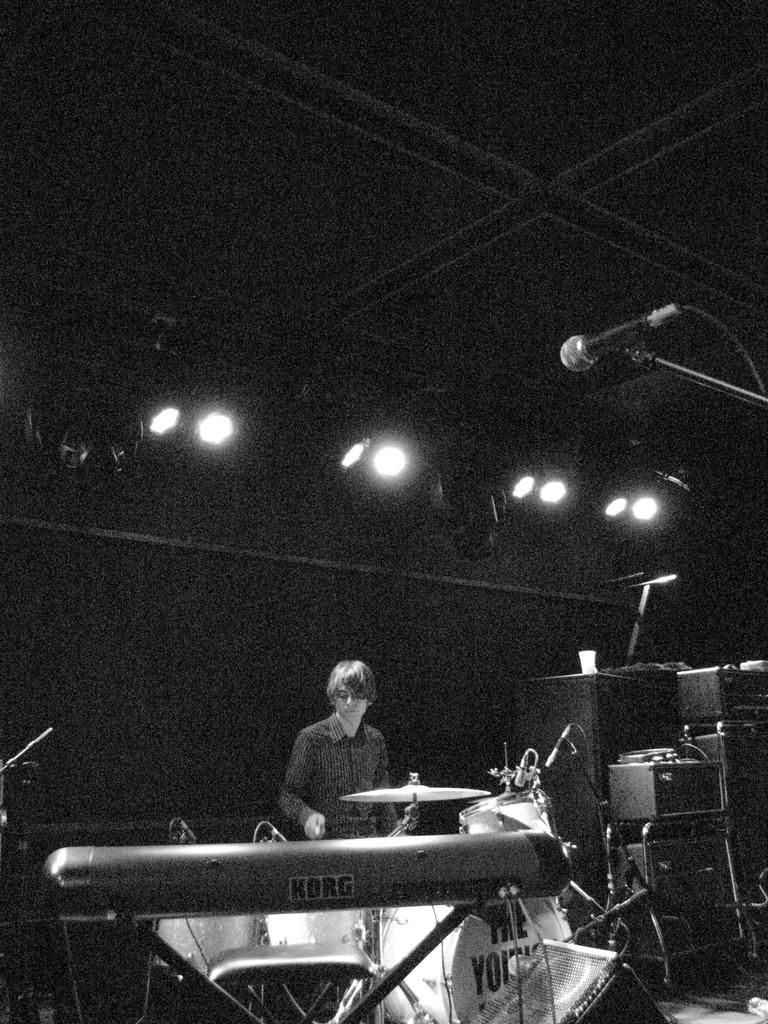What is the color scheme of the image? The image is black and white. What can be seen on the floor in the image? There is a person standing on the floor in the image. What objects are related to music in the image? Musical instruments, mics, and electric lights are present in the image. How many aunts are playing the game with the person in the image? There is no game or aunt present in the image; it features a person standing with musical instruments and mics. 